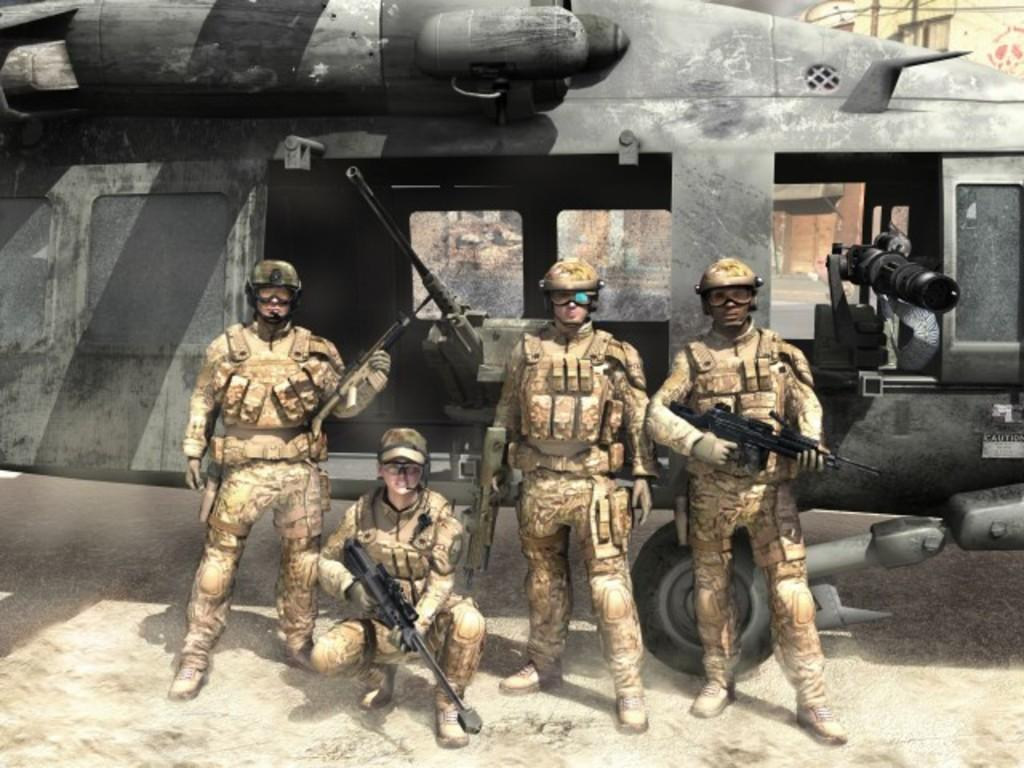What type of picture is in the image? The image contains an animated picture. How many people are present in the image? There are four people in the image. What are the people wearing? The people are wearing uniforms. What are the people holding in their hands? The people are holding guns in their hands. What can be seen in the background of the image? There is a vehicle in the background of the image. What letter is being handed out to the people in the image? There is no letter being handed out in the image; the people are holding guns instead. 